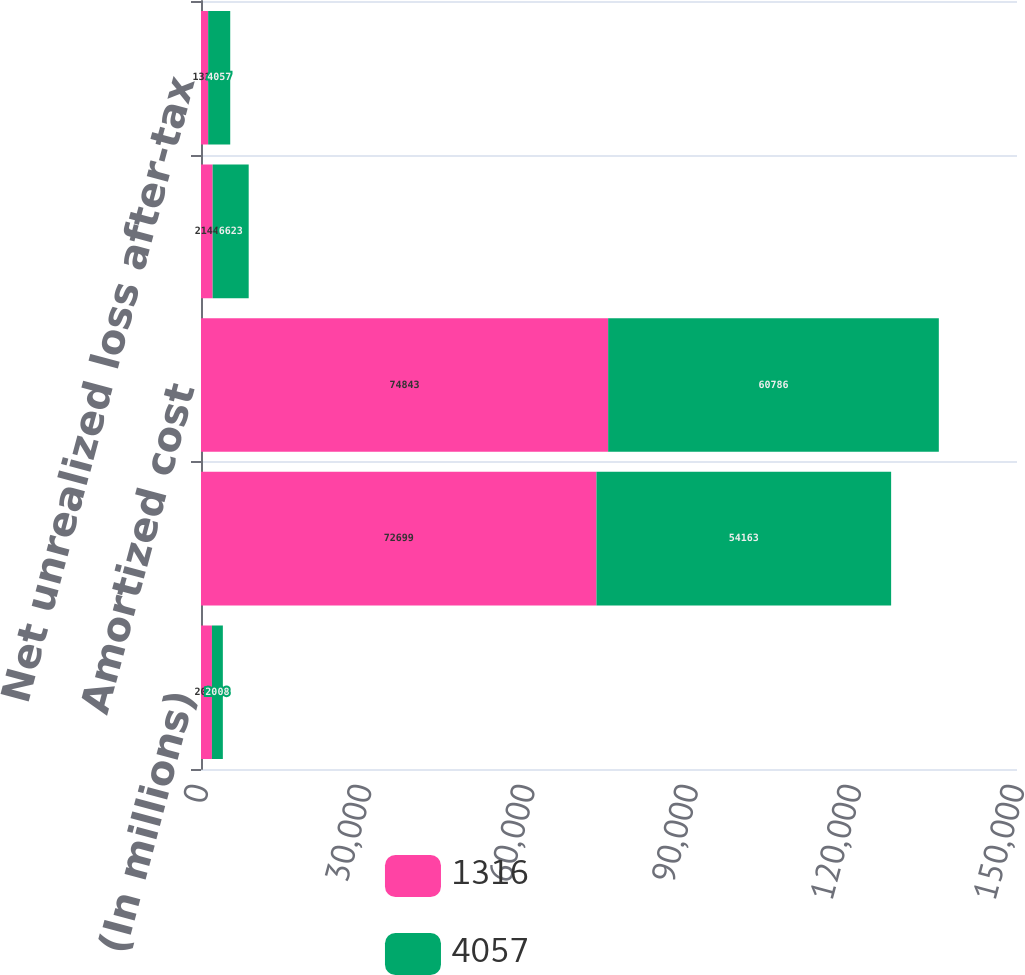<chart> <loc_0><loc_0><loc_500><loc_500><stacked_bar_chart><ecel><fcel>(In millions)<fcel>Fair value<fcel>Amortized cost<fcel>Net unrealized loss pre-tax<fcel>Net unrealized loss after-tax<nl><fcel>1316<fcel>2009<fcel>72699<fcel>74843<fcel>2144<fcel>1316<nl><fcel>4057<fcel>2008<fcel>54163<fcel>60786<fcel>6623<fcel>4057<nl></chart> 